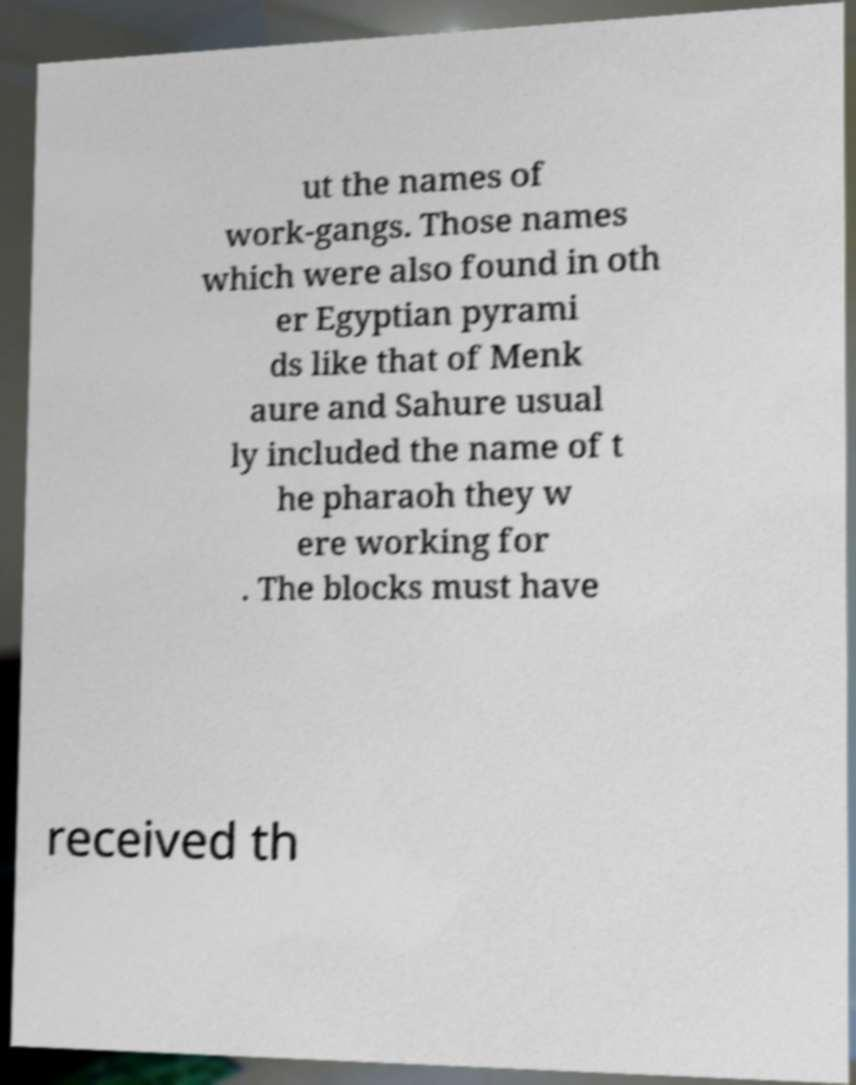What messages or text are displayed in this image? I need them in a readable, typed format. ut the names of work-gangs. Those names which were also found in oth er Egyptian pyrami ds like that of Menk aure and Sahure usual ly included the name of t he pharaoh they w ere working for . The blocks must have received th 